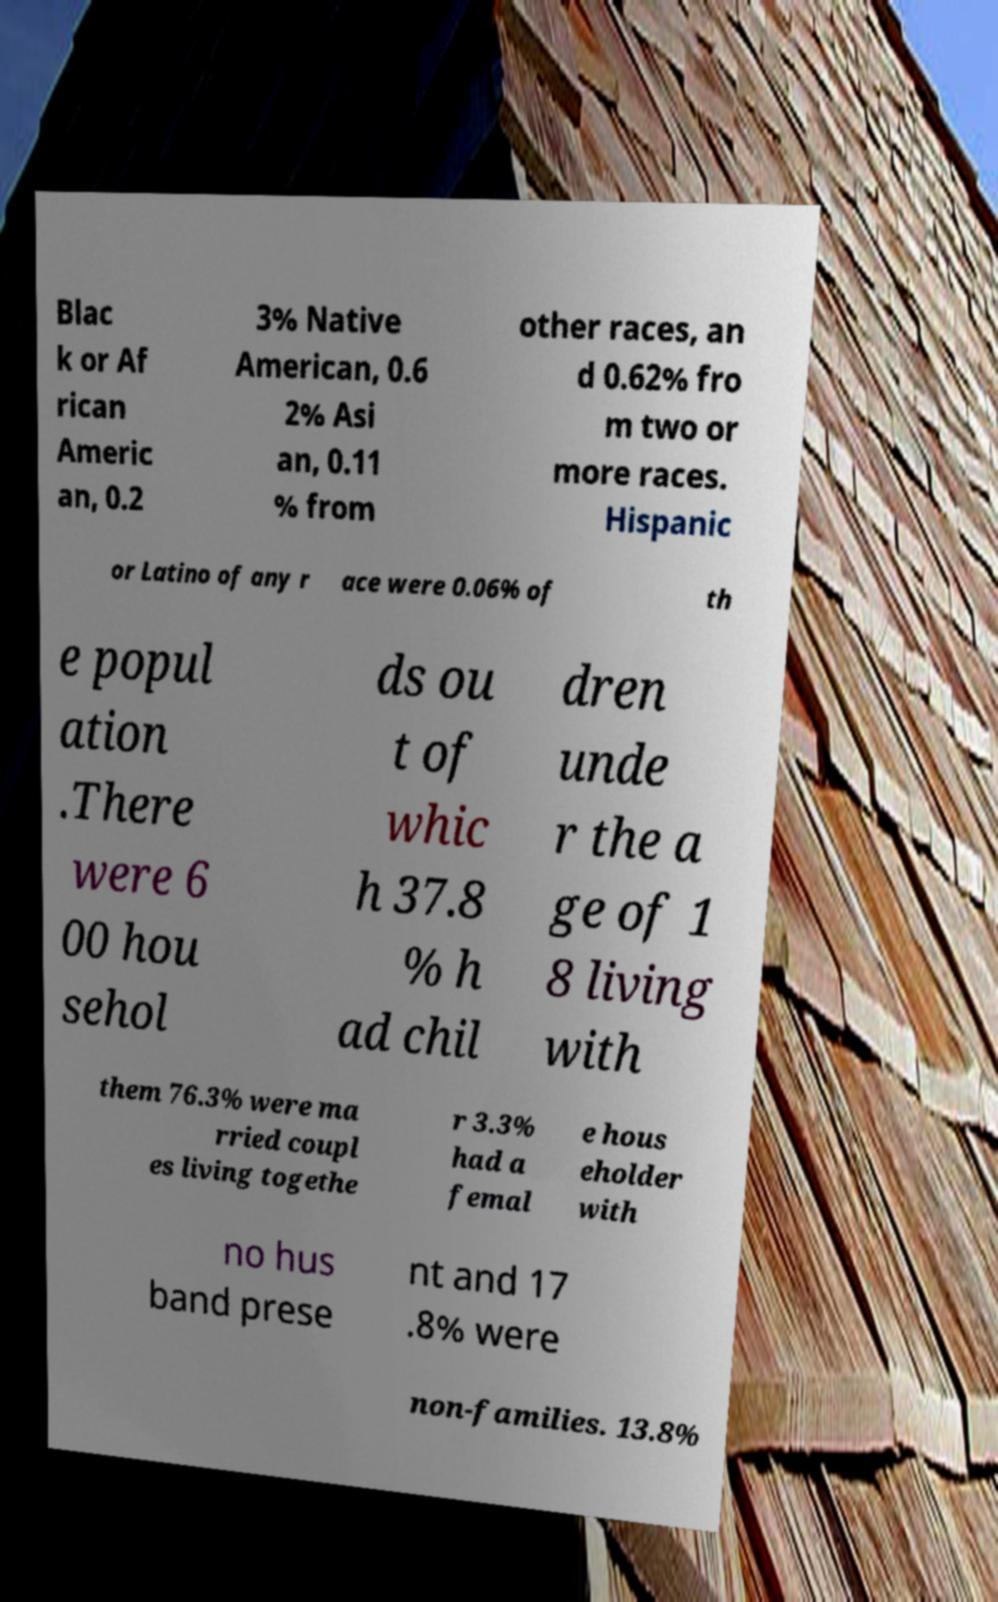For documentation purposes, I need the text within this image transcribed. Could you provide that? Blac k or Af rican Americ an, 0.2 3% Native American, 0.6 2% Asi an, 0.11 % from other races, an d 0.62% fro m two or more races. Hispanic or Latino of any r ace were 0.06% of th e popul ation .There were 6 00 hou sehol ds ou t of whic h 37.8 % h ad chil dren unde r the a ge of 1 8 living with them 76.3% were ma rried coupl es living togethe r 3.3% had a femal e hous eholder with no hus band prese nt and 17 .8% were non-families. 13.8% 